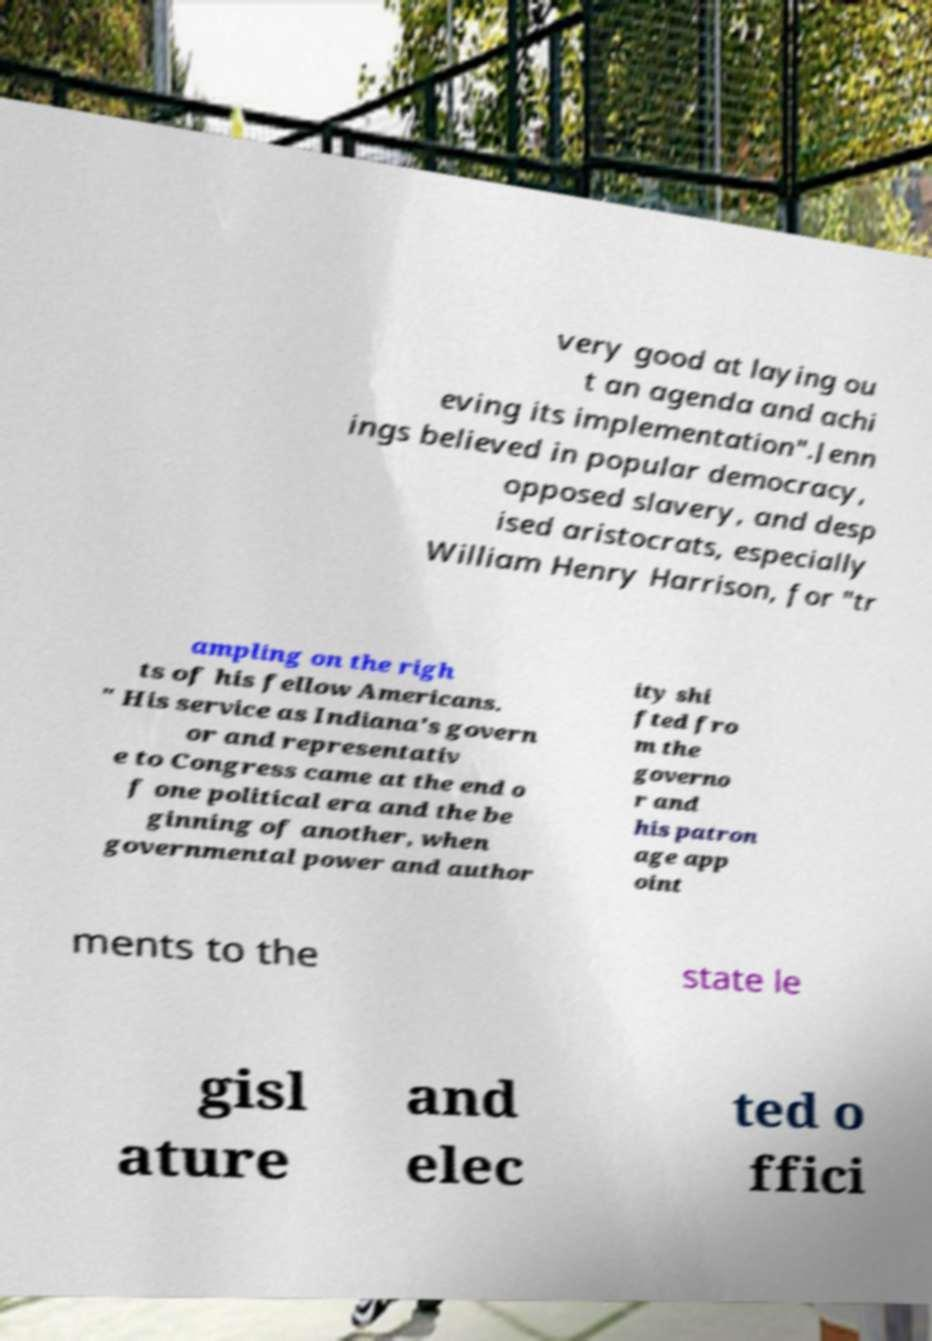Could you assist in decoding the text presented in this image and type it out clearly? very good at laying ou t an agenda and achi eving its implementation".Jenn ings believed in popular democracy, opposed slavery, and desp ised aristocrats, especially William Henry Harrison, for "tr ampling on the righ ts of his fellow Americans. " His service as Indiana's govern or and representativ e to Congress came at the end o f one political era and the be ginning of another, when governmental power and author ity shi fted fro m the governo r and his patron age app oint ments to the state le gisl ature and elec ted o ffici 